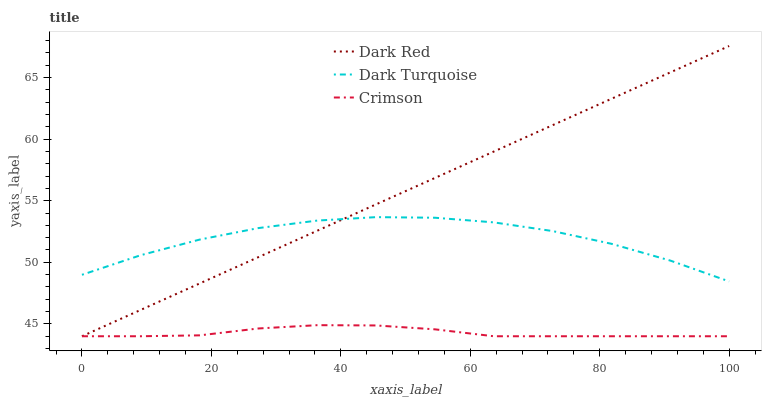Does Crimson have the minimum area under the curve?
Answer yes or no. Yes. Does Dark Red have the maximum area under the curve?
Answer yes or no. Yes. Does Dark Turquoise have the minimum area under the curve?
Answer yes or no. No. Does Dark Turquoise have the maximum area under the curve?
Answer yes or no. No. Is Dark Red the smoothest?
Answer yes or no. Yes. Is Dark Turquoise the roughest?
Answer yes or no. Yes. Is Dark Turquoise the smoothest?
Answer yes or no. No. Is Dark Red the roughest?
Answer yes or no. No. Does Crimson have the lowest value?
Answer yes or no. Yes. Does Dark Turquoise have the lowest value?
Answer yes or no. No. Does Dark Red have the highest value?
Answer yes or no. Yes. Does Dark Turquoise have the highest value?
Answer yes or no. No. Is Crimson less than Dark Turquoise?
Answer yes or no. Yes. Is Dark Turquoise greater than Crimson?
Answer yes or no. Yes. Does Dark Red intersect Dark Turquoise?
Answer yes or no. Yes. Is Dark Red less than Dark Turquoise?
Answer yes or no. No. Is Dark Red greater than Dark Turquoise?
Answer yes or no. No. Does Crimson intersect Dark Turquoise?
Answer yes or no. No. 